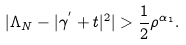<formula> <loc_0><loc_0><loc_500><loc_500>| \Lambda _ { N } - | \gamma ^ { ^ { \prime } } + t | ^ { 2 } | > \frac { 1 } { 2 } \rho ^ { \alpha _ { 1 } } .</formula> 